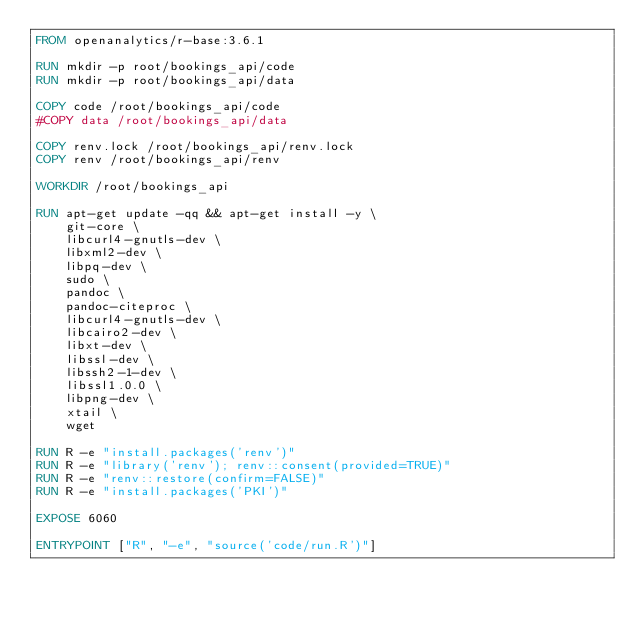Convert code to text. <code><loc_0><loc_0><loc_500><loc_500><_Dockerfile_>FROM openanalytics/r-base:3.6.1

RUN mkdir -p root/bookings_api/code
RUN mkdir -p root/bookings_api/data

COPY code /root/bookings_api/code
#COPY data /root/bookings_api/data

COPY renv.lock /root/bookings_api/renv.lock
COPY renv /root/bookings_api/renv

WORKDIR /root/bookings_api 

RUN apt-get update -qq && apt-get install -y \
	git-core \
  	libcurl4-gnutls-dev \
	libxml2-dev \
	libpq-dev \
    sudo \
    pandoc \
    pandoc-citeproc \
    libcurl4-gnutls-dev \
    libcairo2-dev \
    libxt-dev \
    libssl-dev \
    libssh2-1-dev \
    libssl1.0.0 \
    libpng-dev \
    xtail \
    wget

RUN R -e "install.packages('renv')"
RUN R -e "library('renv'); renv::consent(provided=TRUE)"
RUN R -e "renv::restore(confirm=FALSE)"
RUN R -e "install.packages('PKI')"
    
EXPOSE 6060

ENTRYPOINT ["R", "-e", "source('code/run.R')"]
</code> 